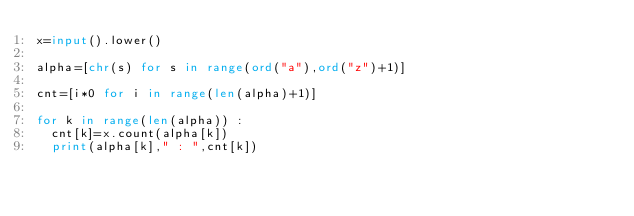<code> <loc_0><loc_0><loc_500><loc_500><_Python_>x=input().lower()

alpha=[chr(s) for s in range(ord("a"),ord("z")+1)]

cnt=[i*0 for i in range(len(alpha)+1)]

for k in range(len(alpha)) :
  cnt[k]=x.count(alpha[k])
  print(alpha[k]," : ",cnt[k])</code> 